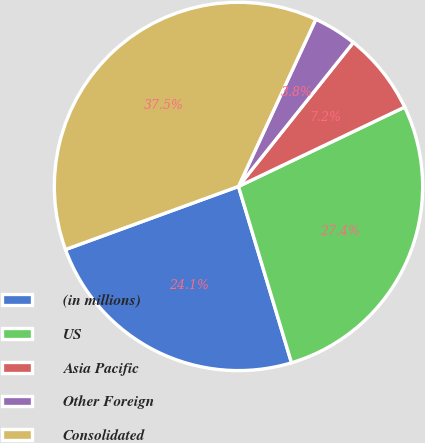<chart> <loc_0><loc_0><loc_500><loc_500><pie_chart><fcel>(in millions)<fcel>US<fcel>Asia Pacific<fcel>Other Foreign<fcel>Consolidated<nl><fcel>24.08%<fcel>27.44%<fcel>7.19%<fcel>3.82%<fcel>37.46%<nl></chart> 